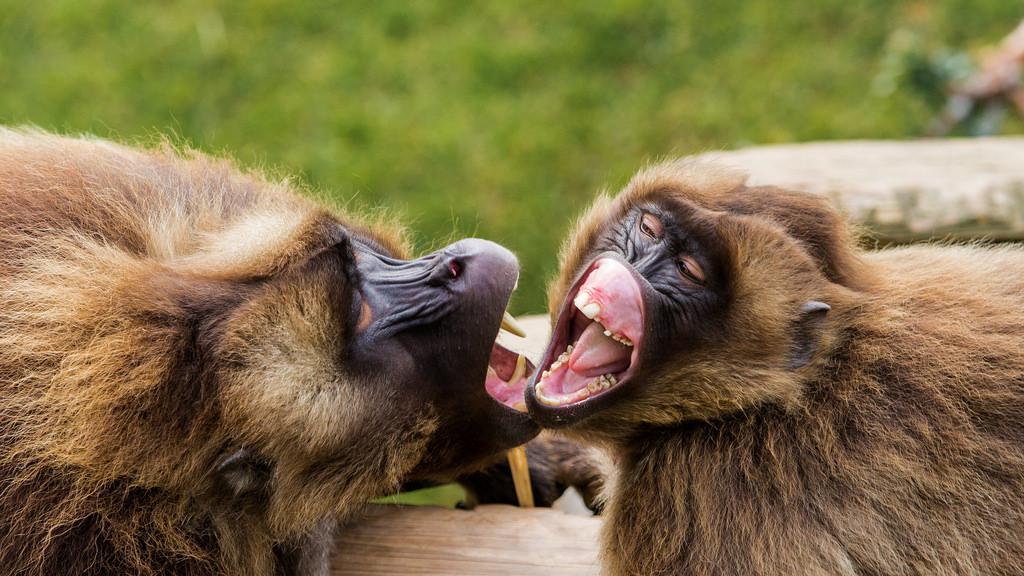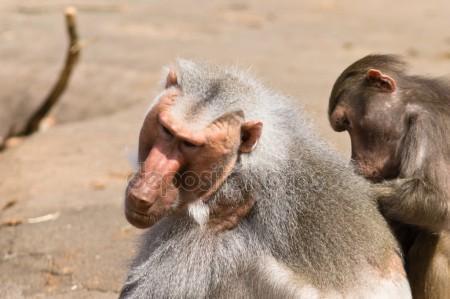The first image is the image on the left, the second image is the image on the right. Given the left and right images, does the statement "An image contains two open-mouthed monkeys posed face-to-face." hold true? Answer yes or no. Yes. The first image is the image on the left, the second image is the image on the right. Examine the images to the left and right. Is the description "A monkey is picking another's back in one of the images." accurate? Answer yes or no. Yes. 